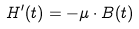<formula> <loc_0><loc_0><loc_500><loc_500>H ^ { \prime } ( t ) = - \mu \cdot B ( t )</formula> 